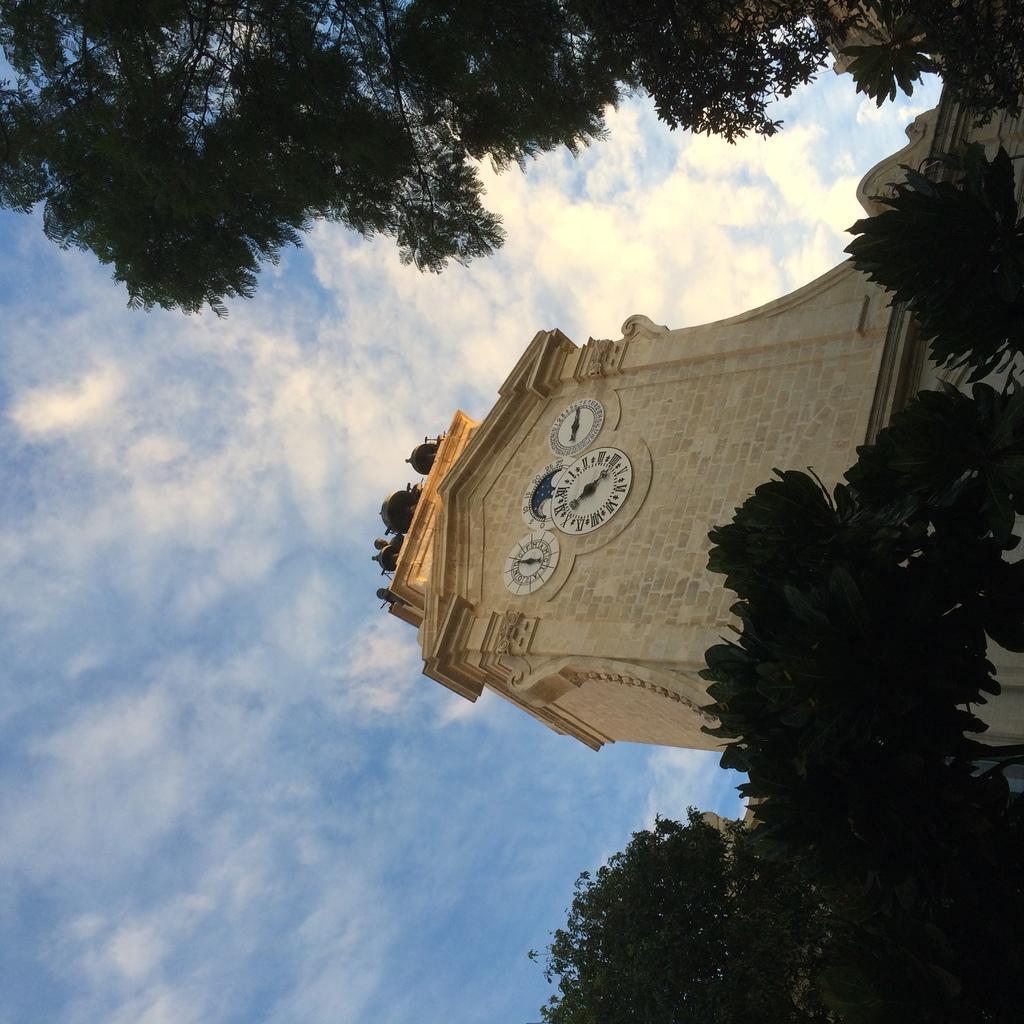Could you give a brief overview of what you see in this image? In this image there is a clock tower in the middle of this image. There are some trees on the right side of this image and on the top of this image as well. There is a cloudy sky in the background. 